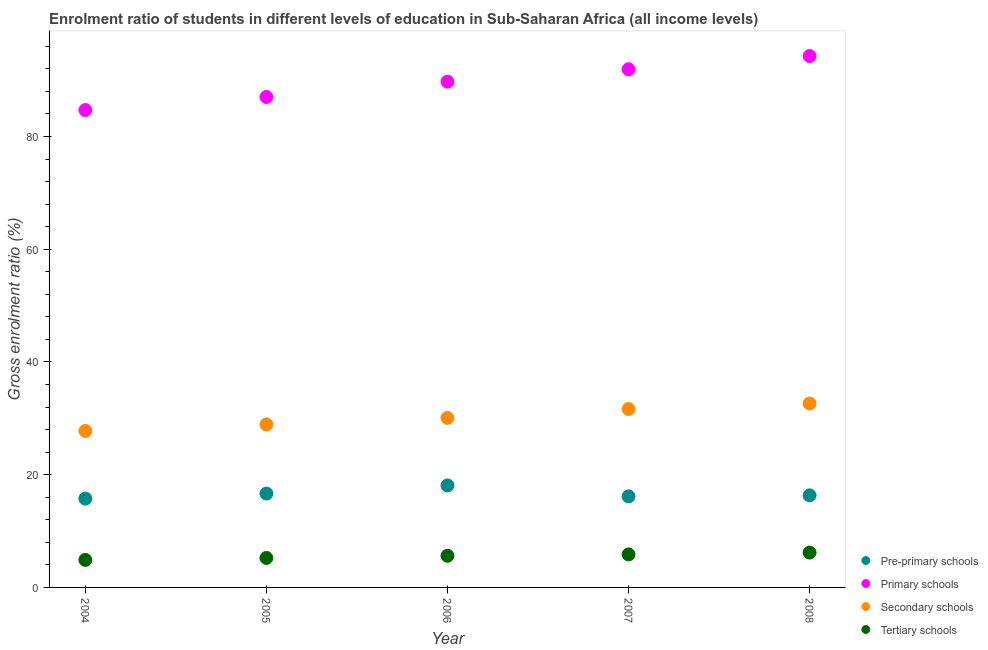What is the gross enrolment ratio in pre-primary schools in 2006?
Provide a short and direct response. 18.1. Across all years, what is the maximum gross enrolment ratio in primary schools?
Offer a very short reply. 94.28. Across all years, what is the minimum gross enrolment ratio in tertiary schools?
Your answer should be very brief. 4.88. In which year was the gross enrolment ratio in tertiary schools maximum?
Your response must be concise. 2008. What is the total gross enrolment ratio in pre-primary schools in the graph?
Your answer should be compact. 83.01. What is the difference between the gross enrolment ratio in primary schools in 2004 and that in 2006?
Offer a terse response. -5.03. What is the difference between the gross enrolment ratio in primary schools in 2005 and the gross enrolment ratio in secondary schools in 2004?
Make the answer very short. 59.25. What is the average gross enrolment ratio in primary schools per year?
Offer a very short reply. 89.53. In the year 2008, what is the difference between the gross enrolment ratio in tertiary schools and gross enrolment ratio in pre-primary schools?
Provide a short and direct response. -10.16. What is the ratio of the gross enrolment ratio in pre-primary schools in 2005 to that in 2008?
Your answer should be very brief. 1.02. Is the gross enrolment ratio in secondary schools in 2004 less than that in 2008?
Your answer should be compact. Yes. Is the difference between the gross enrolment ratio in secondary schools in 2007 and 2008 greater than the difference between the gross enrolment ratio in primary schools in 2007 and 2008?
Provide a succinct answer. Yes. What is the difference between the highest and the second highest gross enrolment ratio in secondary schools?
Provide a succinct answer. 0.99. What is the difference between the highest and the lowest gross enrolment ratio in pre-primary schools?
Provide a short and direct response. 2.35. Is it the case that in every year, the sum of the gross enrolment ratio in secondary schools and gross enrolment ratio in primary schools is greater than the sum of gross enrolment ratio in pre-primary schools and gross enrolment ratio in tertiary schools?
Provide a short and direct response. No. Does the gross enrolment ratio in tertiary schools monotonically increase over the years?
Your response must be concise. Yes. Is the gross enrolment ratio in tertiary schools strictly greater than the gross enrolment ratio in pre-primary schools over the years?
Make the answer very short. No. Is the gross enrolment ratio in primary schools strictly less than the gross enrolment ratio in pre-primary schools over the years?
Your answer should be compact. No. How many dotlines are there?
Keep it short and to the point. 4. What is the difference between two consecutive major ticks on the Y-axis?
Offer a very short reply. 20. Does the graph contain any zero values?
Your response must be concise. No. Does the graph contain grids?
Your answer should be very brief. No. How many legend labels are there?
Make the answer very short. 4. How are the legend labels stacked?
Provide a short and direct response. Vertical. What is the title of the graph?
Your answer should be compact. Enrolment ratio of students in different levels of education in Sub-Saharan Africa (all income levels). What is the label or title of the X-axis?
Your response must be concise. Year. What is the label or title of the Y-axis?
Your answer should be very brief. Gross enrolment ratio (%). What is the Gross enrolment ratio (%) in Pre-primary schools in 2004?
Your answer should be compact. 15.75. What is the Gross enrolment ratio (%) in Primary schools in 2004?
Make the answer very short. 84.7. What is the Gross enrolment ratio (%) of Secondary schools in 2004?
Make the answer very short. 27.76. What is the Gross enrolment ratio (%) of Tertiary schools in 2004?
Offer a very short reply. 4.88. What is the Gross enrolment ratio (%) of Pre-primary schools in 2005?
Offer a terse response. 16.66. What is the Gross enrolment ratio (%) of Primary schools in 2005?
Offer a terse response. 87.02. What is the Gross enrolment ratio (%) of Secondary schools in 2005?
Your response must be concise. 28.92. What is the Gross enrolment ratio (%) in Tertiary schools in 2005?
Offer a terse response. 5.23. What is the Gross enrolment ratio (%) of Pre-primary schools in 2006?
Make the answer very short. 18.1. What is the Gross enrolment ratio (%) of Primary schools in 2006?
Keep it short and to the point. 89.73. What is the Gross enrolment ratio (%) of Secondary schools in 2006?
Your answer should be very brief. 30.08. What is the Gross enrolment ratio (%) of Tertiary schools in 2006?
Offer a terse response. 5.61. What is the Gross enrolment ratio (%) of Pre-primary schools in 2007?
Make the answer very short. 16.16. What is the Gross enrolment ratio (%) of Primary schools in 2007?
Make the answer very short. 91.93. What is the Gross enrolment ratio (%) of Secondary schools in 2007?
Your response must be concise. 31.65. What is the Gross enrolment ratio (%) in Tertiary schools in 2007?
Your response must be concise. 5.86. What is the Gross enrolment ratio (%) of Pre-primary schools in 2008?
Give a very brief answer. 16.34. What is the Gross enrolment ratio (%) in Primary schools in 2008?
Your answer should be very brief. 94.28. What is the Gross enrolment ratio (%) in Secondary schools in 2008?
Your answer should be very brief. 32.64. What is the Gross enrolment ratio (%) in Tertiary schools in 2008?
Give a very brief answer. 6.18. Across all years, what is the maximum Gross enrolment ratio (%) in Pre-primary schools?
Keep it short and to the point. 18.1. Across all years, what is the maximum Gross enrolment ratio (%) in Primary schools?
Provide a succinct answer. 94.28. Across all years, what is the maximum Gross enrolment ratio (%) of Secondary schools?
Ensure brevity in your answer.  32.64. Across all years, what is the maximum Gross enrolment ratio (%) in Tertiary schools?
Ensure brevity in your answer.  6.18. Across all years, what is the minimum Gross enrolment ratio (%) of Pre-primary schools?
Offer a very short reply. 15.75. Across all years, what is the minimum Gross enrolment ratio (%) in Primary schools?
Offer a very short reply. 84.7. Across all years, what is the minimum Gross enrolment ratio (%) in Secondary schools?
Ensure brevity in your answer.  27.76. Across all years, what is the minimum Gross enrolment ratio (%) in Tertiary schools?
Your answer should be very brief. 4.88. What is the total Gross enrolment ratio (%) in Pre-primary schools in the graph?
Your answer should be compact. 83.01. What is the total Gross enrolment ratio (%) of Primary schools in the graph?
Offer a terse response. 447.67. What is the total Gross enrolment ratio (%) in Secondary schools in the graph?
Ensure brevity in your answer.  151.06. What is the total Gross enrolment ratio (%) of Tertiary schools in the graph?
Provide a short and direct response. 27.77. What is the difference between the Gross enrolment ratio (%) of Pre-primary schools in 2004 and that in 2005?
Make the answer very short. -0.9. What is the difference between the Gross enrolment ratio (%) in Primary schools in 2004 and that in 2005?
Give a very brief answer. -2.32. What is the difference between the Gross enrolment ratio (%) in Secondary schools in 2004 and that in 2005?
Your response must be concise. -1.16. What is the difference between the Gross enrolment ratio (%) in Tertiary schools in 2004 and that in 2005?
Keep it short and to the point. -0.35. What is the difference between the Gross enrolment ratio (%) in Pre-primary schools in 2004 and that in 2006?
Provide a short and direct response. -2.35. What is the difference between the Gross enrolment ratio (%) of Primary schools in 2004 and that in 2006?
Your response must be concise. -5.03. What is the difference between the Gross enrolment ratio (%) of Secondary schools in 2004 and that in 2006?
Give a very brief answer. -2.32. What is the difference between the Gross enrolment ratio (%) of Tertiary schools in 2004 and that in 2006?
Give a very brief answer. -0.73. What is the difference between the Gross enrolment ratio (%) of Pre-primary schools in 2004 and that in 2007?
Ensure brevity in your answer.  -0.4. What is the difference between the Gross enrolment ratio (%) of Primary schools in 2004 and that in 2007?
Keep it short and to the point. -7.24. What is the difference between the Gross enrolment ratio (%) of Secondary schools in 2004 and that in 2007?
Make the answer very short. -3.89. What is the difference between the Gross enrolment ratio (%) of Tertiary schools in 2004 and that in 2007?
Your answer should be compact. -0.98. What is the difference between the Gross enrolment ratio (%) in Pre-primary schools in 2004 and that in 2008?
Keep it short and to the point. -0.59. What is the difference between the Gross enrolment ratio (%) in Primary schools in 2004 and that in 2008?
Your answer should be compact. -9.58. What is the difference between the Gross enrolment ratio (%) of Secondary schools in 2004 and that in 2008?
Give a very brief answer. -4.87. What is the difference between the Gross enrolment ratio (%) in Tertiary schools in 2004 and that in 2008?
Provide a short and direct response. -1.3. What is the difference between the Gross enrolment ratio (%) in Pre-primary schools in 2005 and that in 2006?
Ensure brevity in your answer.  -1.44. What is the difference between the Gross enrolment ratio (%) of Primary schools in 2005 and that in 2006?
Your response must be concise. -2.71. What is the difference between the Gross enrolment ratio (%) in Secondary schools in 2005 and that in 2006?
Provide a succinct answer. -1.16. What is the difference between the Gross enrolment ratio (%) in Tertiary schools in 2005 and that in 2006?
Your answer should be very brief. -0.38. What is the difference between the Gross enrolment ratio (%) of Pre-primary schools in 2005 and that in 2007?
Keep it short and to the point. 0.5. What is the difference between the Gross enrolment ratio (%) in Primary schools in 2005 and that in 2007?
Give a very brief answer. -4.92. What is the difference between the Gross enrolment ratio (%) in Secondary schools in 2005 and that in 2007?
Your response must be concise. -2.73. What is the difference between the Gross enrolment ratio (%) in Tertiary schools in 2005 and that in 2007?
Your response must be concise. -0.63. What is the difference between the Gross enrolment ratio (%) in Pre-primary schools in 2005 and that in 2008?
Your answer should be compact. 0.31. What is the difference between the Gross enrolment ratio (%) in Primary schools in 2005 and that in 2008?
Provide a succinct answer. -7.26. What is the difference between the Gross enrolment ratio (%) in Secondary schools in 2005 and that in 2008?
Your answer should be very brief. -3.72. What is the difference between the Gross enrolment ratio (%) of Tertiary schools in 2005 and that in 2008?
Give a very brief answer. -0.95. What is the difference between the Gross enrolment ratio (%) in Pre-primary schools in 2006 and that in 2007?
Offer a terse response. 1.94. What is the difference between the Gross enrolment ratio (%) in Primary schools in 2006 and that in 2007?
Offer a very short reply. -2.2. What is the difference between the Gross enrolment ratio (%) in Secondary schools in 2006 and that in 2007?
Ensure brevity in your answer.  -1.57. What is the difference between the Gross enrolment ratio (%) in Tertiary schools in 2006 and that in 2007?
Keep it short and to the point. -0.25. What is the difference between the Gross enrolment ratio (%) in Pre-primary schools in 2006 and that in 2008?
Make the answer very short. 1.76. What is the difference between the Gross enrolment ratio (%) in Primary schools in 2006 and that in 2008?
Offer a terse response. -4.55. What is the difference between the Gross enrolment ratio (%) of Secondary schools in 2006 and that in 2008?
Make the answer very short. -2.55. What is the difference between the Gross enrolment ratio (%) of Tertiary schools in 2006 and that in 2008?
Provide a short and direct response. -0.57. What is the difference between the Gross enrolment ratio (%) in Pre-primary schools in 2007 and that in 2008?
Provide a succinct answer. -0.19. What is the difference between the Gross enrolment ratio (%) in Primary schools in 2007 and that in 2008?
Ensure brevity in your answer.  -2.35. What is the difference between the Gross enrolment ratio (%) in Secondary schools in 2007 and that in 2008?
Offer a terse response. -0.99. What is the difference between the Gross enrolment ratio (%) in Tertiary schools in 2007 and that in 2008?
Offer a terse response. -0.32. What is the difference between the Gross enrolment ratio (%) in Pre-primary schools in 2004 and the Gross enrolment ratio (%) in Primary schools in 2005?
Your response must be concise. -71.27. What is the difference between the Gross enrolment ratio (%) in Pre-primary schools in 2004 and the Gross enrolment ratio (%) in Secondary schools in 2005?
Ensure brevity in your answer.  -13.17. What is the difference between the Gross enrolment ratio (%) of Pre-primary schools in 2004 and the Gross enrolment ratio (%) of Tertiary schools in 2005?
Keep it short and to the point. 10.52. What is the difference between the Gross enrolment ratio (%) of Primary schools in 2004 and the Gross enrolment ratio (%) of Secondary schools in 2005?
Your response must be concise. 55.78. What is the difference between the Gross enrolment ratio (%) of Primary schools in 2004 and the Gross enrolment ratio (%) of Tertiary schools in 2005?
Offer a terse response. 79.46. What is the difference between the Gross enrolment ratio (%) of Secondary schools in 2004 and the Gross enrolment ratio (%) of Tertiary schools in 2005?
Offer a terse response. 22.53. What is the difference between the Gross enrolment ratio (%) of Pre-primary schools in 2004 and the Gross enrolment ratio (%) of Primary schools in 2006?
Provide a succinct answer. -73.98. What is the difference between the Gross enrolment ratio (%) of Pre-primary schools in 2004 and the Gross enrolment ratio (%) of Secondary schools in 2006?
Provide a short and direct response. -14.33. What is the difference between the Gross enrolment ratio (%) of Pre-primary schools in 2004 and the Gross enrolment ratio (%) of Tertiary schools in 2006?
Make the answer very short. 10.14. What is the difference between the Gross enrolment ratio (%) in Primary schools in 2004 and the Gross enrolment ratio (%) in Secondary schools in 2006?
Offer a terse response. 54.62. What is the difference between the Gross enrolment ratio (%) of Primary schools in 2004 and the Gross enrolment ratio (%) of Tertiary schools in 2006?
Give a very brief answer. 79.08. What is the difference between the Gross enrolment ratio (%) of Secondary schools in 2004 and the Gross enrolment ratio (%) of Tertiary schools in 2006?
Your answer should be very brief. 22.15. What is the difference between the Gross enrolment ratio (%) of Pre-primary schools in 2004 and the Gross enrolment ratio (%) of Primary schools in 2007?
Provide a succinct answer. -76.18. What is the difference between the Gross enrolment ratio (%) of Pre-primary schools in 2004 and the Gross enrolment ratio (%) of Secondary schools in 2007?
Make the answer very short. -15.9. What is the difference between the Gross enrolment ratio (%) in Pre-primary schools in 2004 and the Gross enrolment ratio (%) in Tertiary schools in 2007?
Your response must be concise. 9.89. What is the difference between the Gross enrolment ratio (%) of Primary schools in 2004 and the Gross enrolment ratio (%) of Secondary schools in 2007?
Your response must be concise. 53.05. What is the difference between the Gross enrolment ratio (%) in Primary schools in 2004 and the Gross enrolment ratio (%) in Tertiary schools in 2007?
Your answer should be very brief. 78.84. What is the difference between the Gross enrolment ratio (%) in Secondary schools in 2004 and the Gross enrolment ratio (%) in Tertiary schools in 2007?
Give a very brief answer. 21.91. What is the difference between the Gross enrolment ratio (%) of Pre-primary schools in 2004 and the Gross enrolment ratio (%) of Primary schools in 2008?
Your answer should be compact. -78.53. What is the difference between the Gross enrolment ratio (%) in Pre-primary schools in 2004 and the Gross enrolment ratio (%) in Secondary schools in 2008?
Make the answer very short. -16.88. What is the difference between the Gross enrolment ratio (%) in Pre-primary schools in 2004 and the Gross enrolment ratio (%) in Tertiary schools in 2008?
Your answer should be compact. 9.57. What is the difference between the Gross enrolment ratio (%) of Primary schools in 2004 and the Gross enrolment ratio (%) of Secondary schools in 2008?
Your answer should be compact. 52.06. What is the difference between the Gross enrolment ratio (%) of Primary schools in 2004 and the Gross enrolment ratio (%) of Tertiary schools in 2008?
Ensure brevity in your answer.  78.52. What is the difference between the Gross enrolment ratio (%) of Secondary schools in 2004 and the Gross enrolment ratio (%) of Tertiary schools in 2008?
Your response must be concise. 21.58. What is the difference between the Gross enrolment ratio (%) of Pre-primary schools in 2005 and the Gross enrolment ratio (%) of Primary schools in 2006?
Your response must be concise. -73.07. What is the difference between the Gross enrolment ratio (%) of Pre-primary schools in 2005 and the Gross enrolment ratio (%) of Secondary schools in 2006?
Give a very brief answer. -13.43. What is the difference between the Gross enrolment ratio (%) of Pre-primary schools in 2005 and the Gross enrolment ratio (%) of Tertiary schools in 2006?
Your answer should be very brief. 11.04. What is the difference between the Gross enrolment ratio (%) of Primary schools in 2005 and the Gross enrolment ratio (%) of Secondary schools in 2006?
Offer a terse response. 56.94. What is the difference between the Gross enrolment ratio (%) in Primary schools in 2005 and the Gross enrolment ratio (%) in Tertiary schools in 2006?
Give a very brief answer. 81.4. What is the difference between the Gross enrolment ratio (%) of Secondary schools in 2005 and the Gross enrolment ratio (%) of Tertiary schools in 2006?
Give a very brief answer. 23.31. What is the difference between the Gross enrolment ratio (%) of Pre-primary schools in 2005 and the Gross enrolment ratio (%) of Primary schools in 2007?
Offer a very short reply. -75.28. What is the difference between the Gross enrolment ratio (%) in Pre-primary schools in 2005 and the Gross enrolment ratio (%) in Secondary schools in 2007?
Ensure brevity in your answer.  -14.99. What is the difference between the Gross enrolment ratio (%) in Pre-primary schools in 2005 and the Gross enrolment ratio (%) in Tertiary schools in 2007?
Offer a very short reply. 10.8. What is the difference between the Gross enrolment ratio (%) of Primary schools in 2005 and the Gross enrolment ratio (%) of Secondary schools in 2007?
Keep it short and to the point. 55.37. What is the difference between the Gross enrolment ratio (%) of Primary schools in 2005 and the Gross enrolment ratio (%) of Tertiary schools in 2007?
Make the answer very short. 81.16. What is the difference between the Gross enrolment ratio (%) in Secondary schools in 2005 and the Gross enrolment ratio (%) in Tertiary schools in 2007?
Give a very brief answer. 23.06. What is the difference between the Gross enrolment ratio (%) of Pre-primary schools in 2005 and the Gross enrolment ratio (%) of Primary schools in 2008?
Keep it short and to the point. -77.63. What is the difference between the Gross enrolment ratio (%) in Pre-primary schools in 2005 and the Gross enrolment ratio (%) in Secondary schools in 2008?
Your answer should be compact. -15.98. What is the difference between the Gross enrolment ratio (%) in Pre-primary schools in 2005 and the Gross enrolment ratio (%) in Tertiary schools in 2008?
Your response must be concise. 10.48. What is the difference between the Gross enrolment ratio (%) of Primary schools in 2005 and the Gross enrolment ratio (%) of Secondary schools in 2008?
Provide a short and direct response. 54.38. What is the difference between the Gross enrolment ratio (%) of Primary schools in 2005 and the Gross enrolment ratio (%) of Tertiary schools in 2008?
Give a very brief answer. 80.84. What is the difference between the Gross enrolment ratio (%) of Secondary schools in 2005 and the Gross enrolment ratio (%) of Tertiary schools in 2008?
Ensure brevity in your answer.  22.74. What is the difference between the Gross enrolment ratio (%) in Pre-primary schools in 2006 and the Gross enrolment ratio (%) in Primary schools in 2007?
Provide a short and direct response. -73.83. What is the difference between the Gross enrolment ratio (%) in Pre-primary schools in 2006 and the Gross enrolment ratio (%) in Secondary schools in 2007?
Provide a succinct answer. -13.55. What is the difference between the Gross enrolment ratio (%) in Pre-primary schools in 2006 and the Gross enrolment ratio (%) in Tertiary schools in 2007?
Your answer should be very brief. 12.24. What is the difference between the Gross enrolment ratio (%) in Primary schools in 2006 and the Gross enrolment ratio (%) in Secondary schools in 2007?
Offer a terse response. 58.08. What is the difference between the Gross enrolment ratio (%) of Primary schools in 2006 and the Gross enrolment ratio (%) of Tertiary schools in 2007?
Your answer should be compact. 83.87. What is the difference between the Gross enrolment ratio (%) of Secondary schools in 2006 and the Gross enrolment ratio (%) of Tertiary schools in 2007?
Offer a terse response. 24.22. What is the difference between the Gross enrolment ratio (%) in Pre-primary schools in 2006 and the Gross enrolment ratio (%) in Primary schools in 2008?
Offer a very short reply. -76.18. What is the difference between the Gross enrolment ratio (%) of Pre-primary schools in 2006 and the Gross enrolment ratio (%) of Secondary schools in 2008?
Provide a succinct answer. -14.54. What is the difference between the Gross enrolment ratio (%) of Pre-primary schools in 2006 and the Gross enrolment ratio (%) of Tertiary schools in 2008?
Offer a very short reply. 11.92. What is the difference between the Gross enrolment ratio (%) in Primary schools in 2006 and the Gross enrolment ratio (%) in Secondary schools in 2008?
Your response must be concise. 57.09. What is the difference between the Gross enrolment ratio (%) in Primary schools in 2006 and the Gross enrolment ratio (%) in Tertiary schools in 2008?
Keep it short and to the point. 83.55. What is the difference between the Gross enrolment ratio (%) in Secondary schools in 2006 and the Gross enrolment ratio (%) in Tertiary schools in 2008?
Provide a short and direct response. 23.9. What is the difference between the Gross enrolment ratio (%) in Pre-primary schools in 2007 and the Gross enrolment ratio (%) in Primary schools in 2008?
Make the answer very short. -78.13. What is the difference between the Gross enrolment ratio (%) of Pre-primary schools in 2007 and the Gross enrolment ratio (%) of Secondary schools in 2008?
Provide a succinct answer. -16.48. What is the difference between the Gross enrolment ratio (%) in Pre-primary schools in 2007 and the Gross enrolment ratio (%) in Tertiary schools in 2008?
Offer a very short reply. 9.97. What is the difference between the Gross enrolment ratio (%) in Primary schools in 2007 and the Gross enrolment ratio (%) in Secondary schools in 2008?
Your response must be concise. 59.3. What is the difference between the Gross enrolment ratio (%) in Primary schools in 2007 and the Gross enrolment ratio (%) in Tertiary schools in 2008?
Make the answer very short. 85.75. What is the difference between the Gross enrolment ratio (%) of Secondary schools in 2007 and the Gross enrolment ratio (%) of Tertiary schools in 2008?
Ensure brevity in your answer.  25.47. What is the average Gross enrolment ratio (%) of Pre-primary schools per year?
Offer a terse response. 16.6. What is the average Gross enrolment ratio (%) in Primary schools per year?
Your answer should be very brief. 89.53. What is the average Gross enrolment ratio (%) in Secondary schools per year?
Your answer should be very brief. 30.21. What is the average Gross enrolment ratio (%) in Tertiary schools per year?
Offer a terse response. 5.55. In the year 2004, what is the difference between the Gross enrolment ratio (%) in Pre-primary schools and Gross enrolment ratio (%) in Primary schools?
Provide a short and direct response. -68.95. In the year 2004, what is the difference between the Gross enrolment ratio (%) of Pre-primary schools and Gross enrolment ratio (%) of Secondary schools?
Offer a terse response. -12.01. In the year 2004, what is the difference between the Gross enrolment ratio (%) in Pre-primary schools and Gross enrolment ratio (%) in Tertiary schools?
Provide a succinct answer. 10.87. In the year 2004, what is the difference between the Gross enrolment ratio (%) in Primary schools and Gross enrolment ratio (%) in Secondary schools?
Ensure brevity in your answer.  56.93. In the year 2004, what is the difference between the Gross enrolment ratio (%) in Primary schools and Gross enrolment ratio (%) in Tertiary schools?
Your answer should be very brief. 79.82. In the year 2004, what is the difference between the Gross enrolment ratio (%) of Secondary schools and Gross enrolment ratio (%) of Tertiary schools?
Keep it short and to the point. 22.88. In the year 2005, what is the difference between the Gross enrolment ratio (%) in Pre-primary schools and Gross enrolment ratio (%) in Primary schools?
Your answer should be compact. -70.36. In the year 2005, what is the difference between the Gross enrolment ratio (%) in Pre-primary schools and Gross enrolment ratio (%) in Secondary schools?
Offer a very short reply. -12.26. In the year 2005, what is the difference between the Gross enrolment ratio (%) of Pre-primary schools and Gross enrolment ratio (%) of Tertiary schools?
Keep it short and to the point. 11.42. In the year 2005, what is the difference between the Gross enrolment ratio (%) of Primary schools and Gross enrolment ratio (%) of Secondary schools?
Offer a terse response. 58.1. In the year 2005, what is the difference between the Gross enrolment ratio (%) of Primary schools and Gross enrolment ratio (%) of Tertiary schools?
Provide a short and direct response. 81.78. In the year 2005, what is the difference between the Gross enrolment ratio (%) of Secondary schools and Gross enrolment ratio (%) of Tertiary schools?
Your answer should be compact. 23.69. In the year 2006, what is the difference between the Gross enrolment ratio (%) in Pre-primary schools and Gross enrolment ratio (%) in Primary schools?
Your answer should be compact. -71.63. In the year 2006, what is the difference between the Gross enrolment ratio (%) in Pre-primary schools and Gross enrolment ratio (%) in Secondary schools?
Keep it short and to the point. -11.98. In the year 2006, what is the difference between the Gross enrolment ratio (%) in Pre-primary schools and Gross enrolment ratio (%) in Tertiary schools?
Make the answer very short. 12.49. In the year 2006, what is the difference between the Gross enrolment ratio (%) of Primary schools and Gross enrolment ratio (%) of Secondary schools?
Ensure brevity in your answer.  59.65. In the year 2006, what is the difference between the Gross enrolment ratio (%) of Primary schools and Gross enrolment ratio (%) of Tertiary schools?
Ensure brevity in your answer.  84.12. In the year 2006, what is the difference between the Gross enrolment ratio (%) in Secondary schools and Gross enrolment ratio (%) in Tertiary schools?
Make the answer very short. 24.47. In the year 2007, what is the difference between the Gross enrolment ratio (%) of Pre-primary schools and Gross enrolment ratio (%) of Primary schools?
Make the answer very short. -75.78. In the year 2007, what is the difference between the Gross enrolment ratio (%) in Pre-primary schools and Gross enrolment ratio (%) in Secondary schools?
Your response must be concise. -15.5. In the year 2007, what is the difference between the Gross enrolment ratio (%) of Pre-primary schools and Gross enrolment ratio (%) of Tertiary schools?
Ensure brevity in your answer.  10.3. In the year 2007, what is the difference between the Gross enrolment ratio (%) of Primary schools and Gross enrolment ratio (%) of Secondary schools?
Provide a succinct answer. 60.28. In the year 2007, what is the difference between the Gross enrolment ratio (%) of Primary schools and Gross enrolment ratio (%) of Tertiary schools?
Provide a short and direct response. 86.07. In the year 2007, what is the difference between the Gross enrolment ratio (%) of Secondary schools and Gross enrolment ratio (%) of Tertiary schools?
Ensure brevity in your answer.  25.79. In the year 2008, what is the difference between the Gross enrolment ratio (%) of Pre-primary schools and Gross enrolment ratio (%) of Primary schools?
Your response must be concise. -77.94. In the year 2008, what is the difference between the Gross enrolment ratio (%) in Pre-primary schools and Gross enrolment ratio (%) in Secondary schools?
Your answer should be very brief. -16.29. In the year 2008, what is the difference between the Gross enrolment ratio (%) of Pre-primary schools and Gross enrolment ratio (%) of Tertiary schools?
Keep it short and to the point. 10.16. In the year 2008, what is the difference between the Gross enrolment ratio (%) in Primary schools and Gross enrolment ratio (%) in Secondary schools?
Ensure brevity in your answer.  61.64. In the year 2008, what is the difference between the Gross enrolment ratio (%) of Primary schools and Gross enrolment ratio (%) of Tertiary schools?
Your answer should be compact. 88.1. In the year 2008, what is the difference between the Gross enrolment ratio (%) of Secondary schools and Gross enrolment ratio (%) of Tertiary schools?
Make the answer very short. 26.46. What is the ratio of the Gross enrolment ratio (%) in Pre-primary schools in 2004 to that in 2005?
Provide a succinct answer. 0.95. What is the ratio of the Gross enrolment ratio (%) in Primary schools in 2004 to that in 2005?
Provide a short and direct response. 0.97. What is the ratio of the Gross enrolment ratio (%) in Secondary schools in 2004 to that in 2005?
Your answer should be compact. 0.96. What is the ratio of the Gross enrolment ratio (%) in Tertiary schools in 2004 to that in 2005?
Your response must be concise. 0.93. What is the ratio of the Gross enrolment ratio (%) in Pre-primary schools in 2004 to that in 2006?
Your answer should be very brief. 0.87. What is the ratio of the Gross enrolment ratio (%) of Primary schools in 2004 to that in 2006?
Provide a succinct answer. 0.94. What is the ratio of the Gross enrolment ratio (%) of Secondary schools in 2004 to that in 2006?
Provide a short and direct response. 0.92. What is the ratio of the Gross enrolment ratio (%) of Tertiary schools in 2004 to that in 2006?
Make the answer very short. 0.87. What is the ratio of the Gross enrolment ratio (%) of Pre-primary schools in 2004 to that in 2007?
Your answer should be compact. 0.98. What is the ratio of the Gross enrolment ratio (%) in Primary schools in 2004 to that in 2007?
Keep it short and to the point. 0.92. What is the ratio of the Gross enrolment ratio (%) of Secondary schools in 2004 to that in 2007?
Your answer should be compact. 0.88. What is the ratio of the Gross enrolment ratio (%) of Tertiary schools in 2004 to that in 2007?
Provide a short and direct response. 0.83. What is the ratio of the Gross enrolment ratio (%) in Pre-primary schools in 2004 to that in 2008?
Your answer should be very brief. 0.96. What is the ratio of the Gross enrolment ratio (%) in Primary schools in 2004 to that in 2008?
Your answer should be compact. 0.9. What is the ratio of the Gross enrolment ratio (%) in Secondary schools in 2004 to that in 2008?
Keep it short and to the point. 0.85. What is the ratio of the Gross enrolment ratio (%) of Tertiary schools in 2004 to that in 2008?
Make the answer very short. 0.79. What is the ratio of the Gross enrolment ratio (%) of Pre-primary schools in 2005 to that in 2006?
Give a very brief answer. 0.92. What is the ratio of the Gross enrolment ratio (%) of Primary schools in 2005 to that in 2006?
Your response must be concise. 0.97. What is the ratio of the Gross enrolment ratio (%) in Secondary schools in 2005 to that in 2006?
Your answer should be compact. 0.96. What is the ratio of the Gross enrolment ratio (%) in Tertiary schools in 2005 to that in 2006?
Provide a succinct answer. 0.93. What is the ratio of the Gross enrolment ratio (%) of Pre-primary schools in 2005 to that in 2007?
Your response must be concise. 1.03. What is the ratio of the Gross enrolment ratio (%) in Primary schools in 2005 to that in 2007?
Ensure brevity in your answer.  0.95. What is the ratio of the Gross enrolment ratio (%) of Secondary schools in 2005 to that in 2007?
Provide a succinct answer. 0.91. What is the ratio of the Gross enrolment ratio (%) of Tertiary schools in 2005 to that in 2007?
Your answer should be compact. 0.89. What is the ratio of the Gross enrolment ratio (%) in Pre-primary schools in 2005 to that in 2008?
Your answer should be compact. 1.02. What is the ratio of the Gross enrolment ratio (%) in Primary schools in 2005 to that in 2008?
Make the answer very short. 0.92. What is the ratio of the Gross enrolment ratio (%) of Secondary schools in 2005 to that in 2008?
Provide a succinct answer. 0.89. What is the ratio of the Gross enrolment ratio (%) in Tertiary schools in 2005 to that in 2008?
Provide a short and direct response. 0.85. What is the ratio of the Gross enrolment ratio (%) of Pre-primary schools in 2006 to that in 2007?
Your response must be concise. 1.12. What is the ratio of the Gross enrolment ratio (%) of Secondary schools in 2006 to that in 2007?
Offer a very short reply. 0.95. What is the ratio of the Gross enrolment ratio (%) of Tertiary schools in 2006 to that in 2007?
Offer a terse response. 0.96. What is the ratio of the Gross enrolment ratio (%) in Pre-primary schools in 2006 to that in 2008?
Keep it short and to the point. 1.11. What is the ratio of the Gross enrolment ratio (%) in Primary schools in 2006 to that in 2008?
Offer a terse response. 0.95. What is the ratio of the Gross enrolment ratio (%) of Secondary schools in 2006 to that in 2008?
Provide a succinct answer. 0.92. What is the ratio of the Gross enrolment ratio (%) of Tertiary schools in 2006 to that in 2008?
Provide a succinct answer. 0.91. What is the ratio of the Gross enrolment ratio (%) in Pre-primary schools in 2007 to that in 2008?
Give a very brief answer. 0.99. What is the ratio of the Gross enrolment ratio (%) of Primary schools in 2007 to that in 2008?
Your response must be concise. 0.98. What is the ratio of the Gross enrolment ratio (%) in Secondary schools in 2007 to that in 2008?
Keep it short and to the point. 0.97. What is the ratio of the Gross enrolment ratio (%) in Tertiary schools in 2007 to that in 2008?
Offer a very short reply. 0.95. What is the difference between the highest and the second highest Gross enrolment ratio (%) of Pre-primary schools?
Offer a terse response. 1.44. What is the difference between the highest and the second highest Gross enrolment ratio (%) of Primary schools?
Give a very brief answer. 2.35. What is the difference between the highest and the second highest Gross enrolment ratio (%) in Tertiary schools?
Your answer should be compact. 0.32. What is the difference between the highest and the lowest Gross enrolment ratio (%) in Pre-primary schools?
Your answer should be compact. 2.35. What is the difference between the highest and the lowest Gross enrolment ratio (%) of Primary schools?
Ensure brevity in your answer.  9.58. What is the difference between the highest and the lowest Gross enrolment ratio (%) in Secondary schools?
Your answer should be compact. 4.87. What is the difference between the highest and the lowest Gross enrolment ratio (%) in Tertiary schools?
Your answer should be very brief. 1.3. 